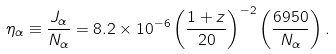Convert formula to latex. <formula><loc_0><loc_0><loc_500><loc_500>\eta _ { \alpha } \equiv \frac { J _ { \alpha } } { N _ { \alpha } } = 8 . 2 \times 1 0 ^ { - 6 } \left ( \frac { 1 + z } { 2 0 } \right ) ^ { - 2 } \left ( \frac { 6 9 5 0 } { N _ { \alpha } } \right ) .</formula> 